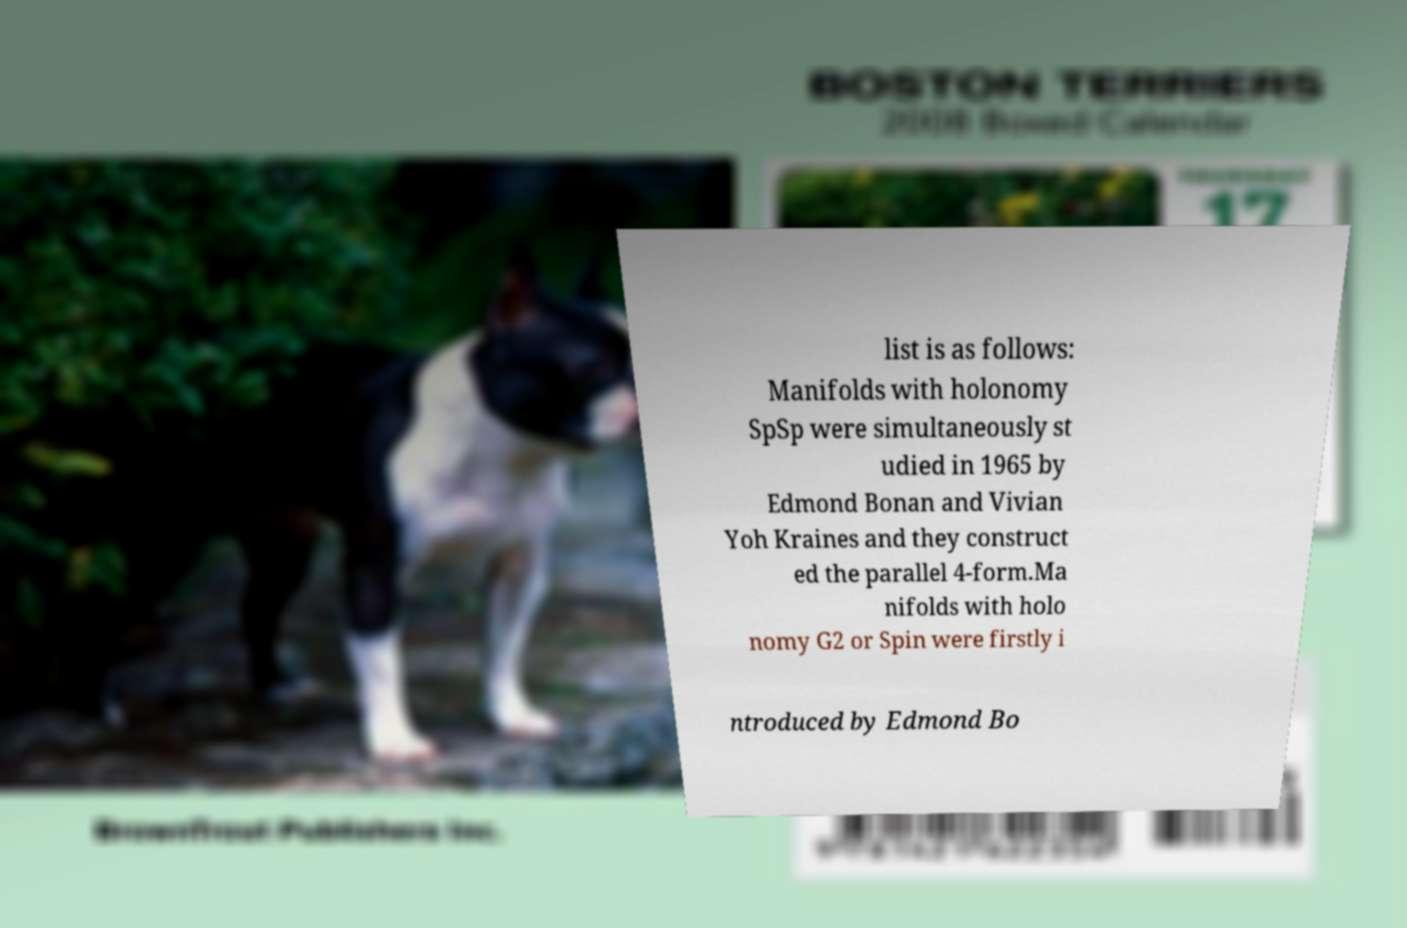Could you extract and type out the text from this image? list is as follows: Manifolds with holonomy SpSp were simultaneously st udied in 1965 by Edmond Bonan and Vivian Yoh Kraines and they construct ed the parallel 4-form.Ma nifolds with holo nomy G2 or Spin were firstly i ntroduced by Edmond Bo 